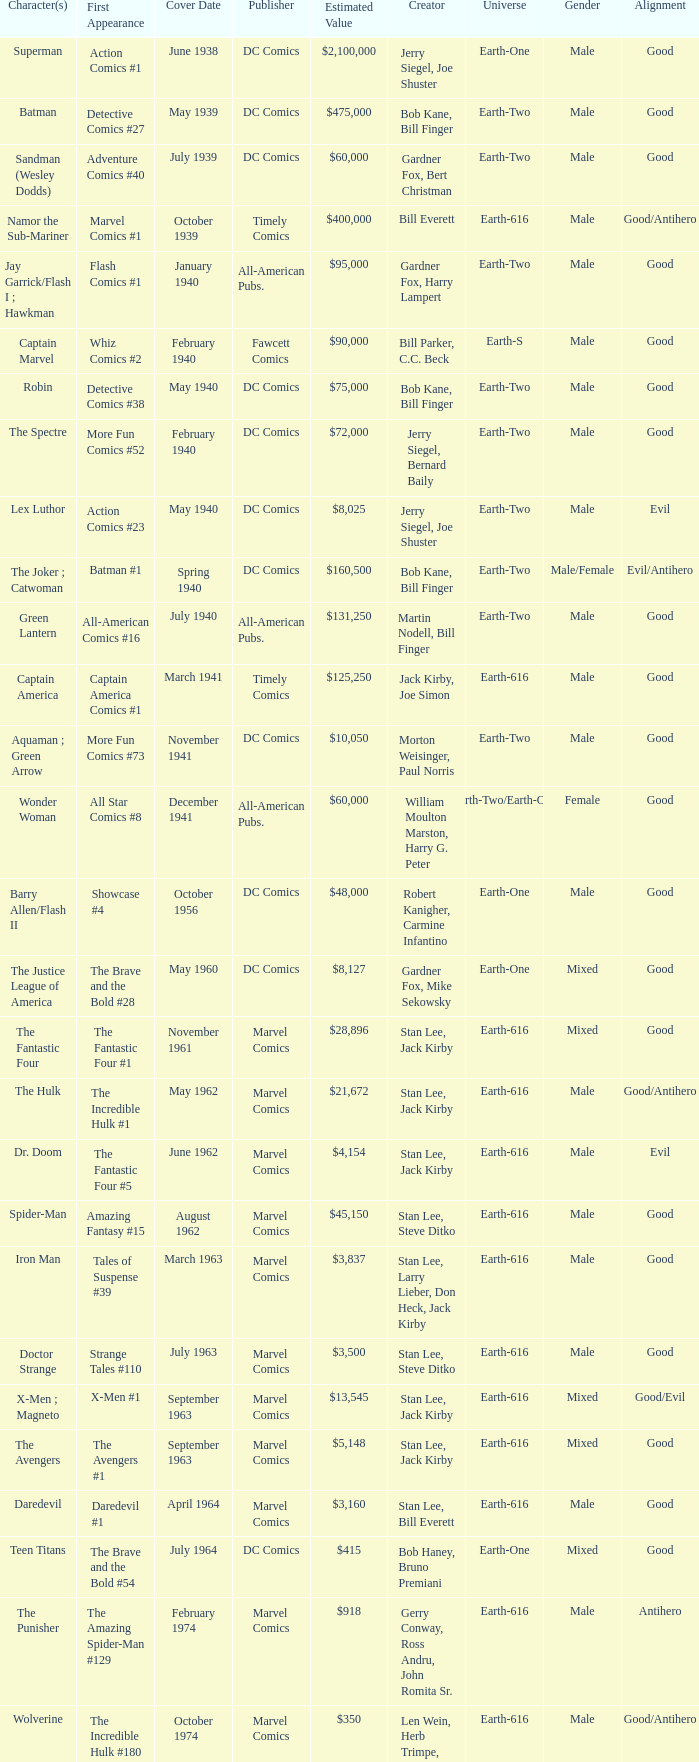Which character first appeared in Amazing Fantasy #15? Spider-Man. 